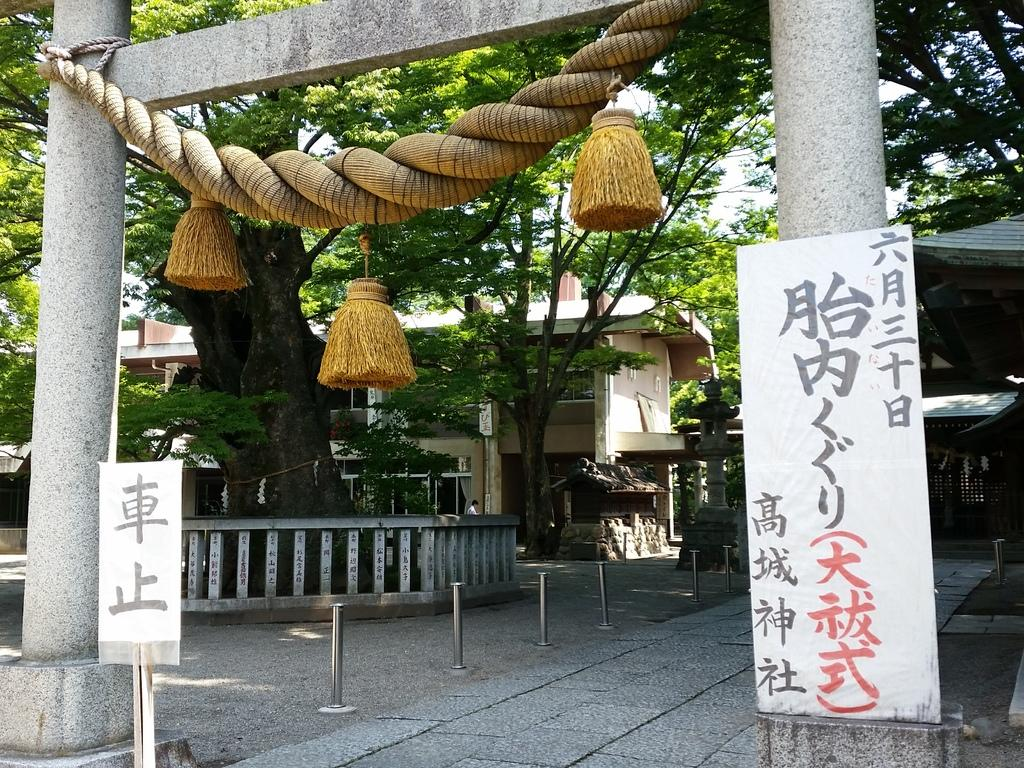What object can be seen in the image that is used for tying or hanging? There is a rope in the image that can be used for tying or hanging. What is the rope connected to in the image? The rope is connected to an arch in the image. What decorative items are present in the image? There are banners in the image, which are attached to poles. What can be seen in the background of the image? In the background of the image, there are trees, buildings, and the sky. What type of trouble does the toad cause in the image? There is no toad present in the image, so it cannot cause any trouble. 